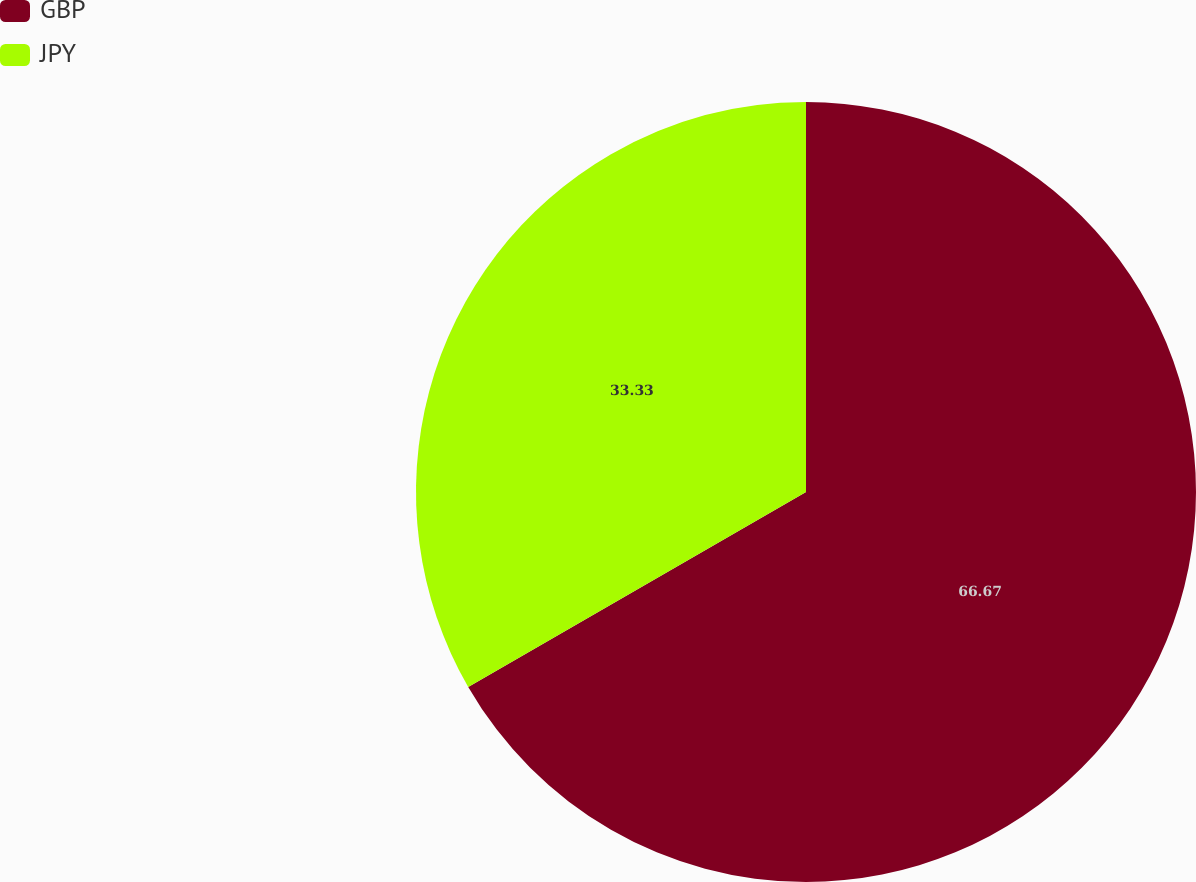<chart> <loc_0><loc_0><loc_500><loc_500><pie_chart><fcel>GBP<fcel>JPY<nl><fcel>66.67%<fcel>33.33%<nl></chart> 